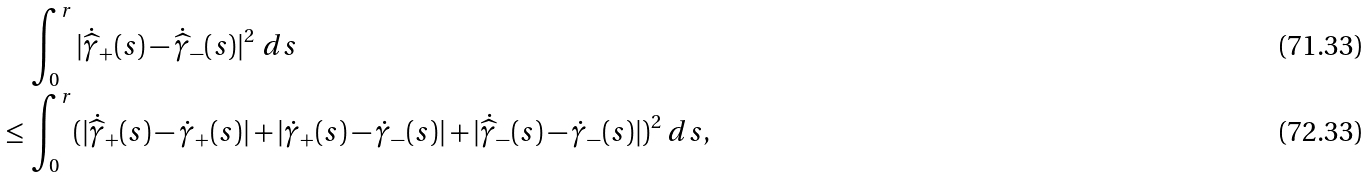Convert formula to latex. <formula><loc_0><loc_0><loc_500><loc_500>& \, \int ^ { r } _ { 0 } | \dot { \widehat { \gamma } } _ { + } ( s ) - \dot { \widehat { \gamma } } _ { - } ( s ) | ^ { 2 } \ d s \\ \leq & \, \int ^ { r } _ { 0 } ( | \dot { \widehat { \gamma } } _ { + } ( s ) - \dot { \gamma } _ { + } ( s ) | + | \dot { \gamma } _ { + } ( s ) - \dot { \gamma } _ { - } ( s ) | + | \dot { \widehat { \gamma } } _ { - } ( s ) - \dot { \gamma } _ { - } ( s ) | ) ^ { 2 } \ d s ,</formula> 